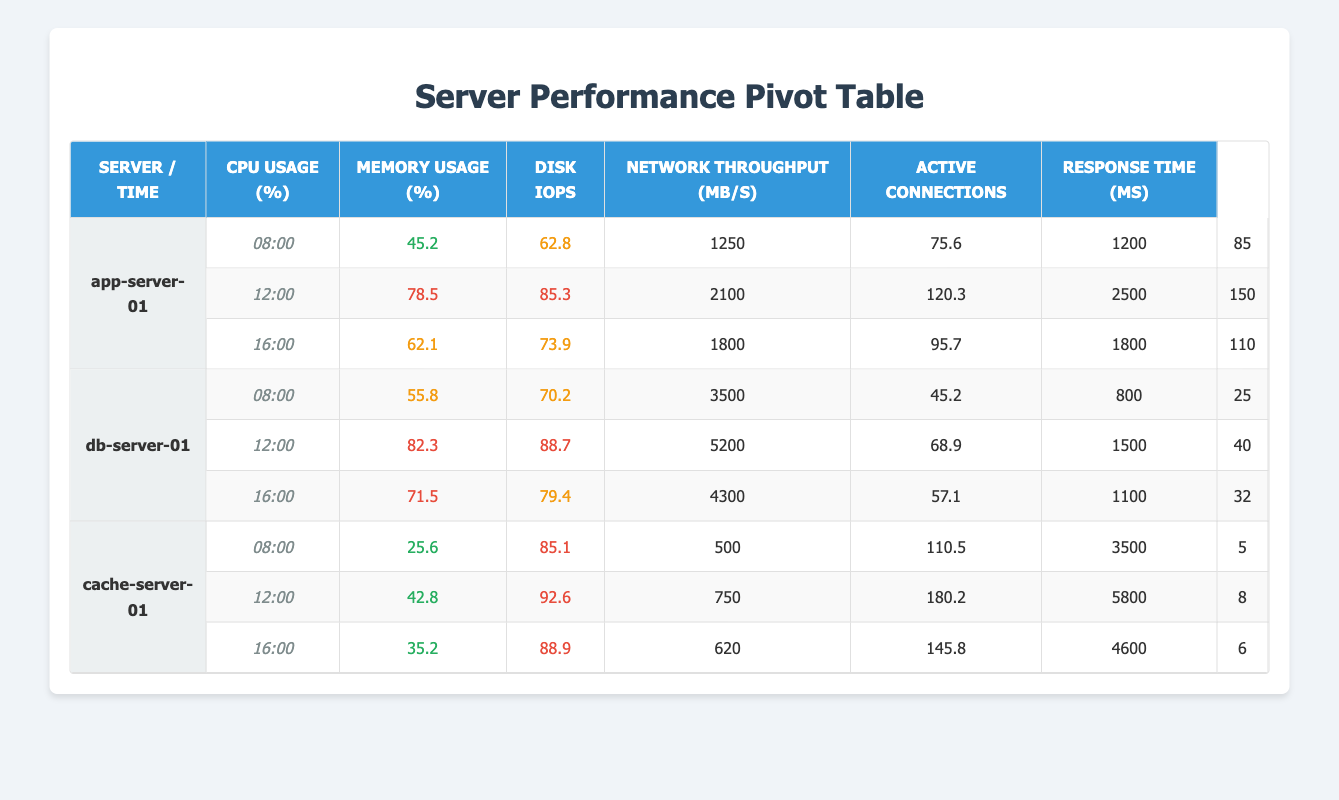What is the CPU usage of app-server-01 at 12:00? The CPU usage for app-server-01 at 12:00 is 78.5, which can be found in the corresponding row in the table.
Answer: 78.5 What is the average memory usage for db-server-01 across all reported times? To find the average memory usage for db-server-01, we sum the memory usage values: (70.2 + 88.7 + 79.4) = 238.3. Then we divide by the number of entries (3), which gives 238.3 / 3 = 79.43.
Answer: 79.43 Is the response time for cache-server-01 always below 10 ms? The response times for cache-server-01 are 5 ms, 8 ms, and 6 ms at 08:00, 12:00, and 16:00 respectively. Since all these values are below 10 ms, the statement is true.
Answer: Yes What server had the highest CPU usage at 16:00? At 16:00, app-server-01 has a CPU usage of 62.1%, db-server-01 has 71.5%, and cache-server-01 has 35.2%. The highest CPU usage is for db-server-01 with 71.5%.
Answer: db-server-01 What is the total number of active connections during the 12:00 hour across all servers? The number of active connections at 12:00 are: app-server-01: 2500, db-server-01: 1500, cache-server-01: 5800. Summing these values gives: 2500 + 1500 + 5800 = 9800 active connections at 12:00.
Answer: 9800 